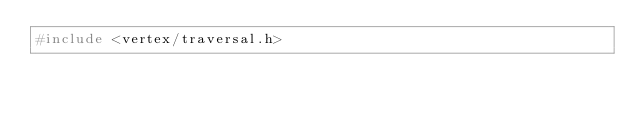<code> <loc_0><loc_0><loc_500><loc_500><_C++_>#include <vertex/traversal.h></code> 